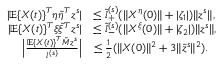<formula> <loc_0><loc_0><loc_500><loc_500>\begin{array} { r l } { | \mathbb { E } \{ X ( t ) \} ^ { T } \eta \tilde { \eta } ^ { T } z ^ { s } | } & { \leq \tilde { l } _ { + } ^ { ( s ) } ( \| X ^ { \eta } ( 0 ) \| + | \zeta _ { 1 } | ) \| z ^ { s } \| , } \\ { | \mathbb { E } \{ X ( t ) \} ^ { T } \xi \tilde { \xi } ^ { T } z ^ { s } | } & { \leq \tilde { l } _ { - } ^ { ( s ) } ( \| X ^ { \xi } ( 0 ) \| + | \zeta _ { 2 } | ) \| z ^ { s } \| , } \\ { \left | \frac { \mathbb { E } \{ X ( t ) \} ^ { T } \tilde { M } z ^ { s } } { l ^ { ( s ) } } \right | } & { \leq \frac { 1 } { 2 } ( \| X ( 0 ) \| ^ { 2 } + 3 \| \tilde { z } ^ { s } \| ^ { 2 } ) . } \end{array}</formula> 